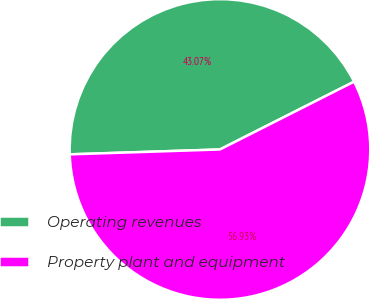Convert chart. <chart><loc_0><loc_0><loc_500><loc_500><pie_chart><fcel>Operating revenues<fcel>Property plant and equipment<nl><fcel>43.07%<fcel>56.93%<nl></chart> 